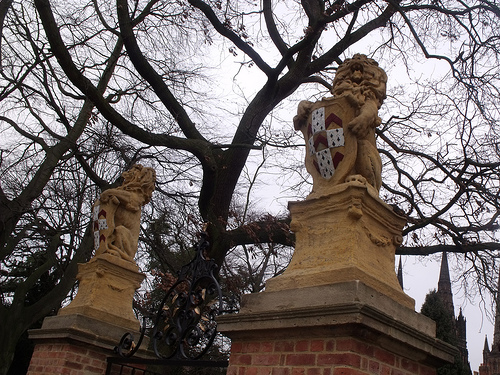<image>
Is the tree on the statue? No. The tree is not positioned on the statue. They may be near each other, but the tree is not supported by or resting on top of the statue. 